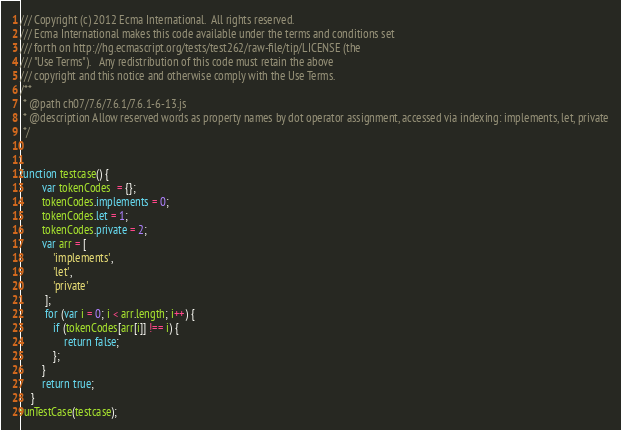<code> <loc_0><loc_0><loc_500><loc_500><_JavaScript_>/// Copyright (c) 2012 Ecma International.  All rights reserved. 
/// Ecma International makes this code available under the terms and conditions set
/// forth on http://hg.ecmascript.org/tests/test262/raw-file/tip/LICENSE (the 
/// "Use Terms").   Any redistribution of this code must retain the above 
/// copyright and this notice and otherwise comply with the Use Terms.
/**
 * @path ch07/7.6/7.6.1/7.6.1-6-13.js
 * @description Allow reserved words as property names by dot operator assignment, accessed via indexing: implements, let, private
 */


function testcase() {
        var tokenCodes  = {};
        tokenCodes.implements = 0;
        tokenCodes.let = 1;
        tokenCodes.private = 2;
        var arr = [
            'implements',
            'let',
            'private'
         ];
         for (var i = 0; i < arr.length; i++) {
            if (tokenCodes[arr[i]] !== i) {
                return false;
            };
        }
        return true;
    }
runTestCase(testcase);
</code> 